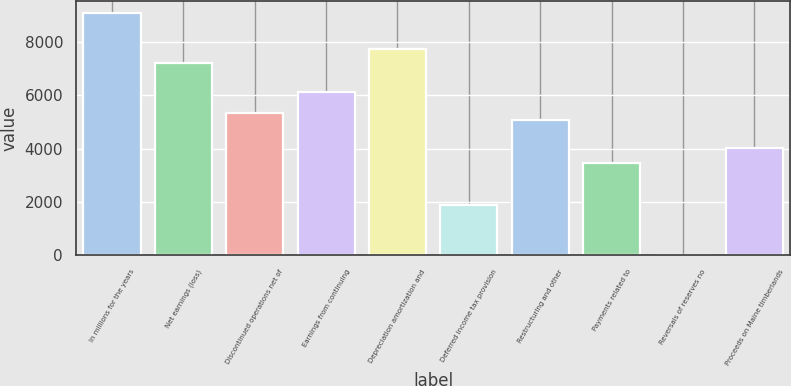Convert chart. <chart><loc_0><loc_0><loc_500><loc_500><bar_chart><fcel>In millions for the years<fcel>Net earnings (loss)<fcel>Discontinued operations net of<fcel>Earnings from continuing<fcel>Depreciation amortization and<fcel>Deferred income tax provision<fcel>Restructuring and other<fcel>Payments related to<fcel>Reversals of reserves no<fcel>Proceeds on Maine timberlands<nl><fcel>9065<fcel>7199.5<fcel>5334<fcel>6133.5<fcel>7732.5<fcel>1869.5<fcel>5067.5<fcel>3468.5<fcel>4<fcel>4001.5<nl></chart> 